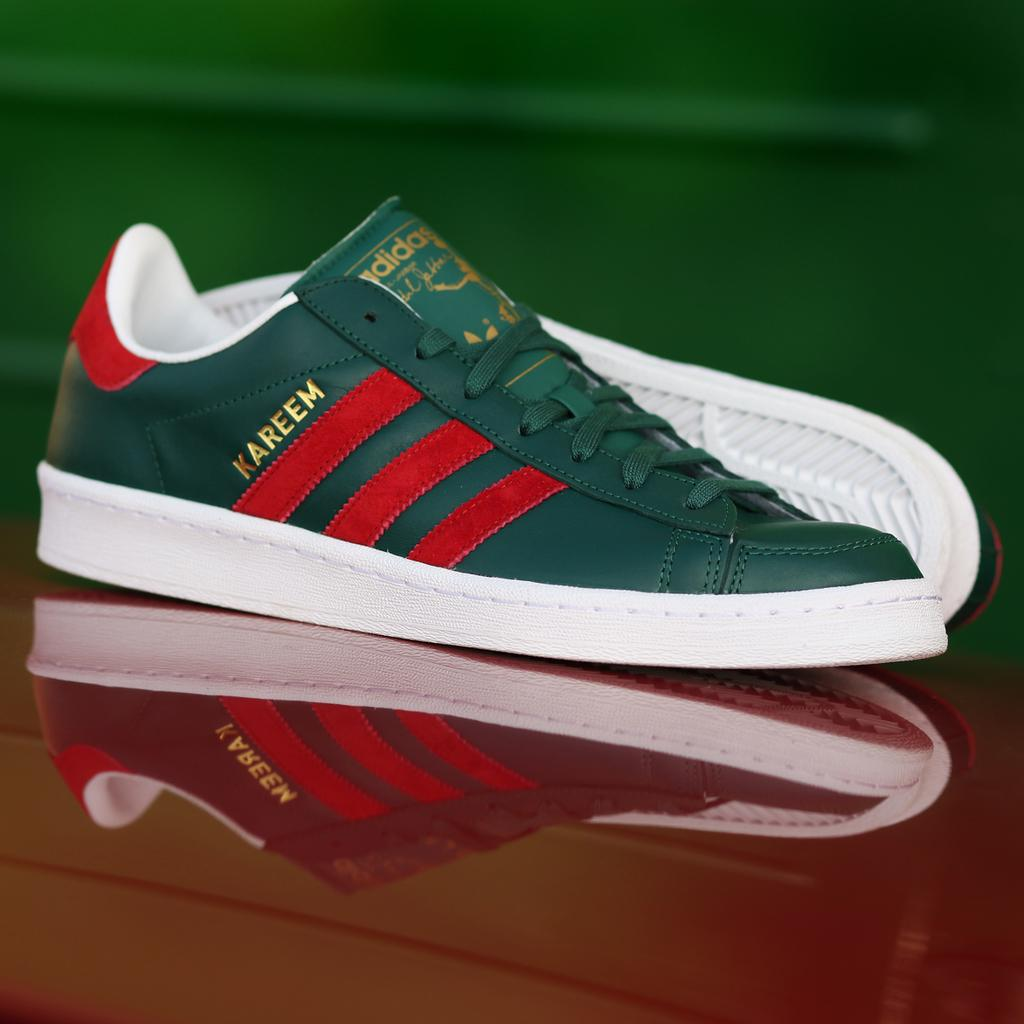What color is the surface that the shoes are placed on in the image? The surface is red. What objects are on the red surface in the image? A pair of shoes is present on the red surface. How would you describe the background of the image? The background of the image is blurry. What color is the background of the image? The background color is green. How many chairs are visible in the image? There are no chairs present in the image. What type of balloon is floating in the background of the image? There is no balloon present in the image. 